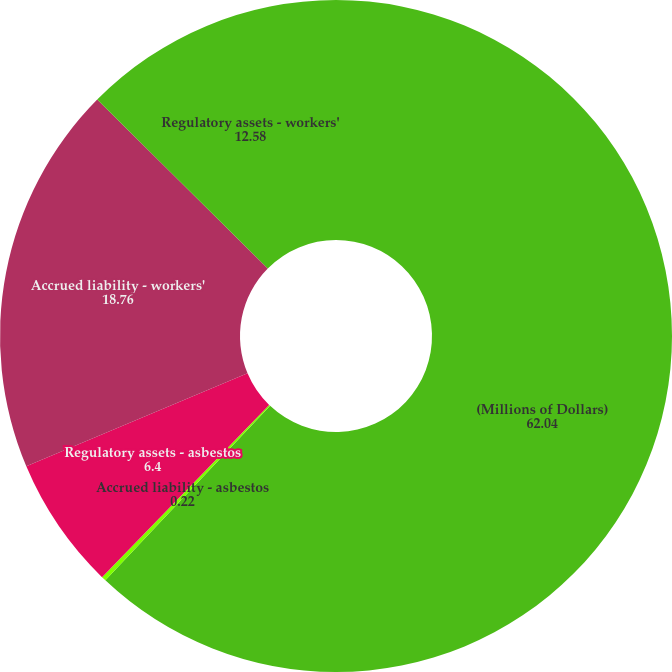Convert chart. <chart><loc_0><loc_0><loc_500><loc_500><pie_chart><fcel>(Millions of Dollars)<fcel>Accrued liability - asbestos<fcel>Regulatory assets - asbestos<fcel>Accrued liability - workers'<fcel>Regulatory assets - workers'<nl><fcel>62.04%<fcel>0.22%<fcel>6.4%<fcel>18.76%<fcel>12.58%<nl></chart> 